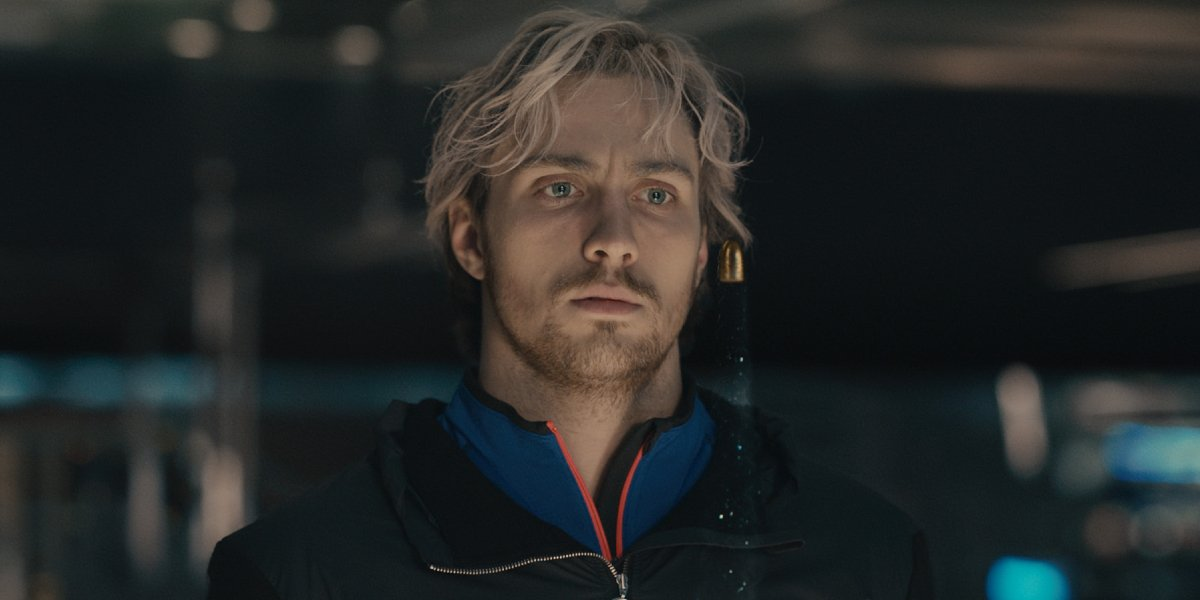An utterly fantastical scenario: What if the man in the image was waiting for a mythical creature? In a twist straight out of a fantasy tale, the man in the image awaits not a person, but a mythical creature. His solemn expression intensifies as the ambient light flickers, signaling the arrival of a dragon. The creature glides silently into the frame, its shimmering scales reflecting myriad colors. As they lock eyes, an unspoken communication passes between them, a pact of mutual respect and shared purpose. The bustling background fades, replaced with an ethereal forest where mystical beings converge. This moment marks the beginning of an epic quest, one where the man and his mythical companion will uncover ancient secrets and battle formidable foes. 